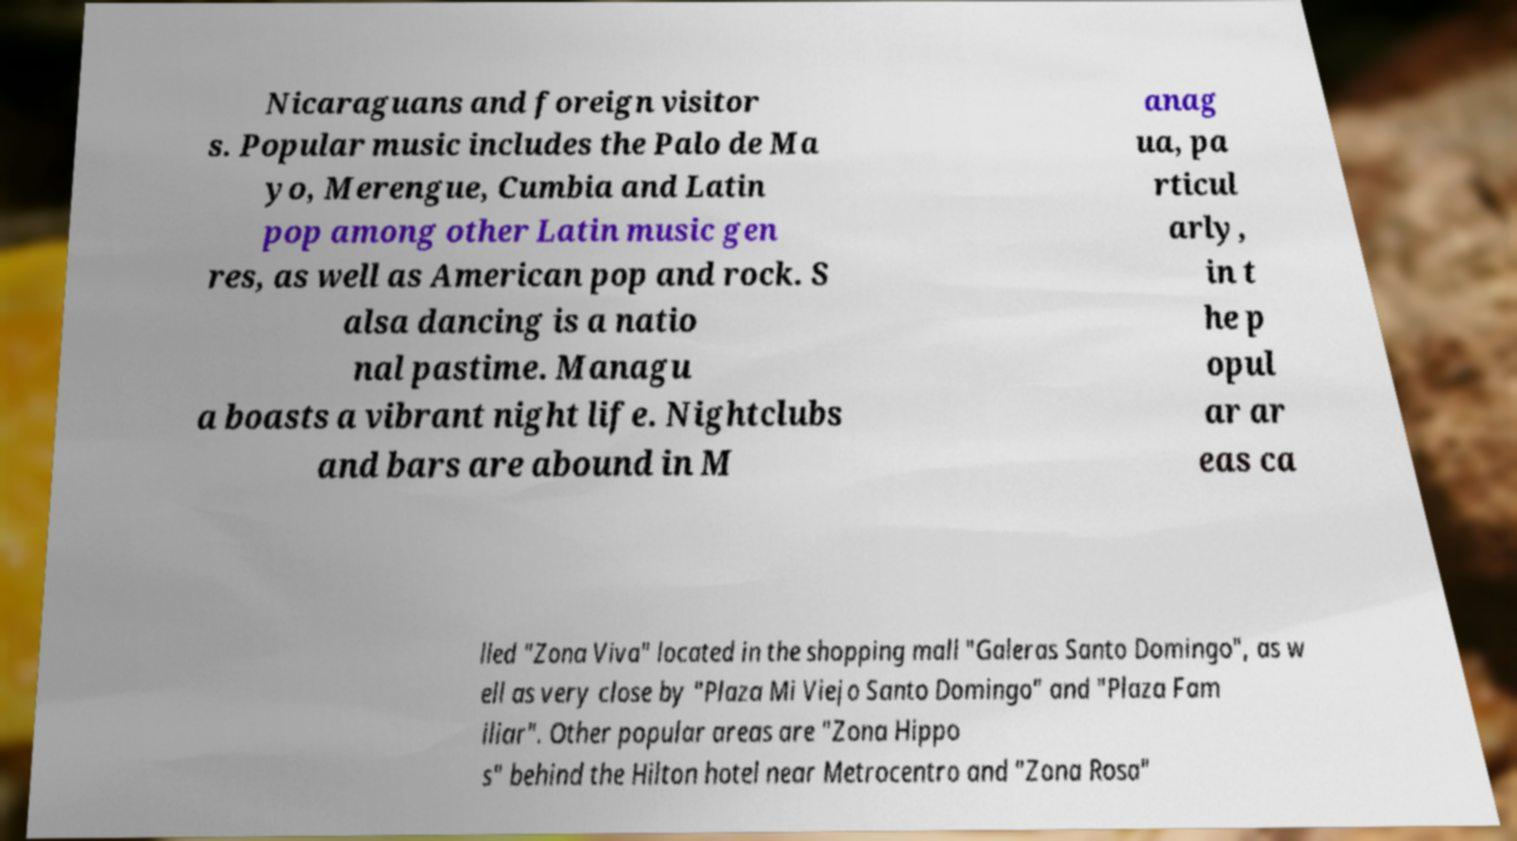Could you extract and type out the text from this image? Nicaraguans and foreign visitor s. Popular music includes the Palo de Ma yo, Merengue, Cumbia and Latin pop among other Latin music gen res, as well as American pop and rock. S alsa dancing is a natio nal pastime. Managu a boasts a vibrant night life. Nightclubs and bars are abound in M anag ua, pa rticul arly, in t he p opul ar ar eas ca lled "Zona Viva" located in the shopping mall "Galeras Santo Domingo", as w ell as very close by "Plaza Mi Viejo Santo Domingo" and "Plaza Fam iliar". Other popular areas are "Zona Hippo s" behind the Hilton hotel near Metrocentro and "Zona Rosa" 